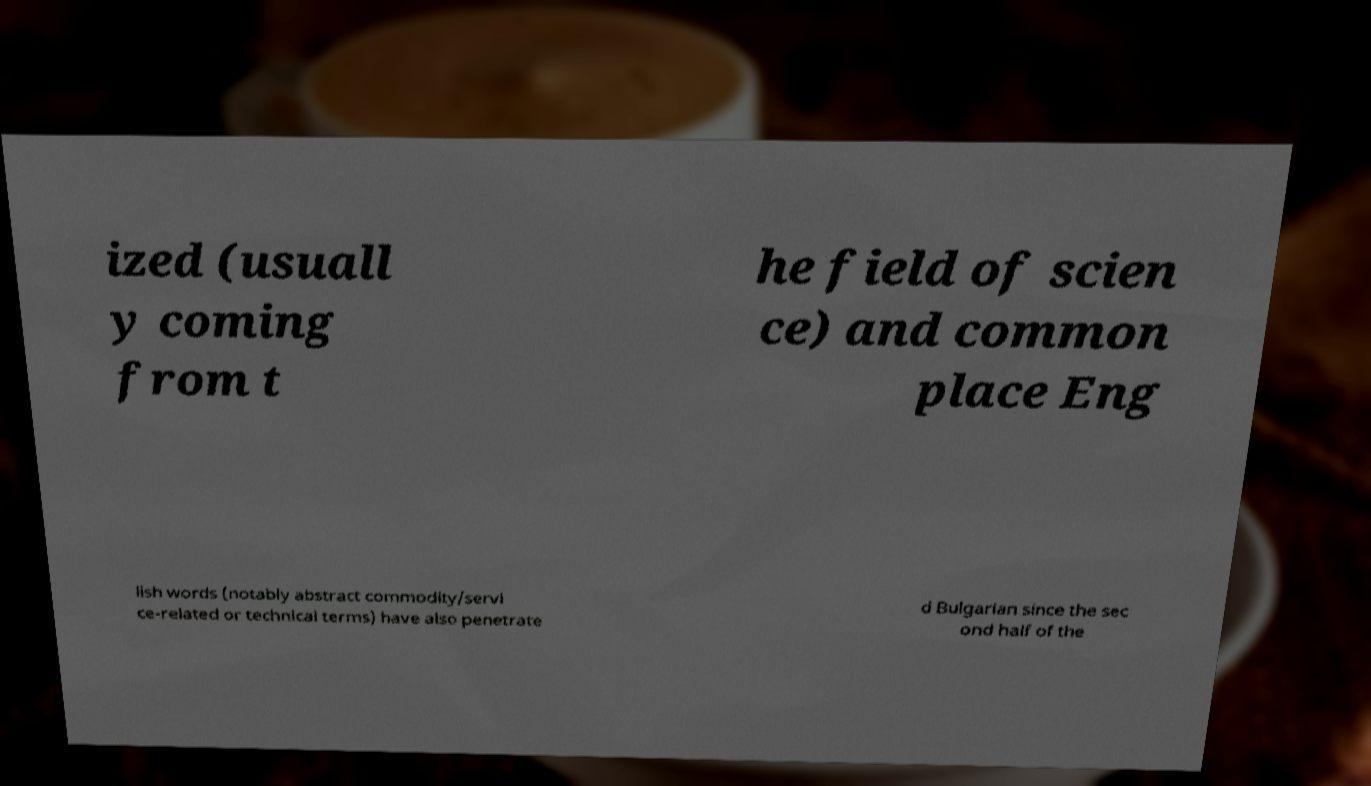Could you extract and type out the text from this image? ized (usuall y coming from t he field of scien ce) and common place Eng lish words (notably abstract commodity/servi ce-related or technical terms) have also penetrate d Bulgarian since the sec ond half of the 